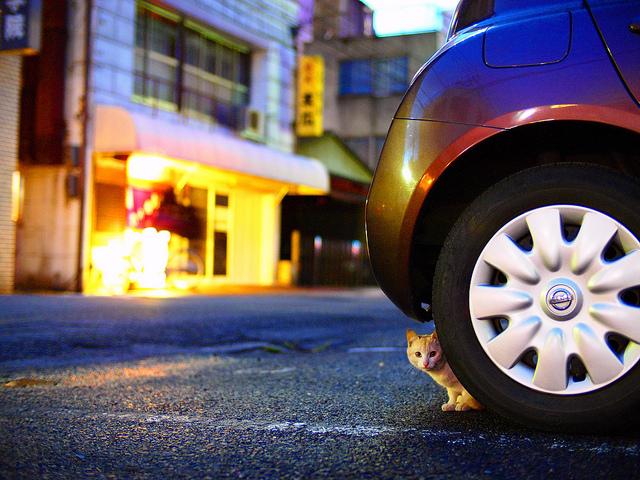Is the cat hurt?
Keep it brief. No. Is the street busy?
Concise answer only. No. Is it night time?
Concise answer only. Yes. 